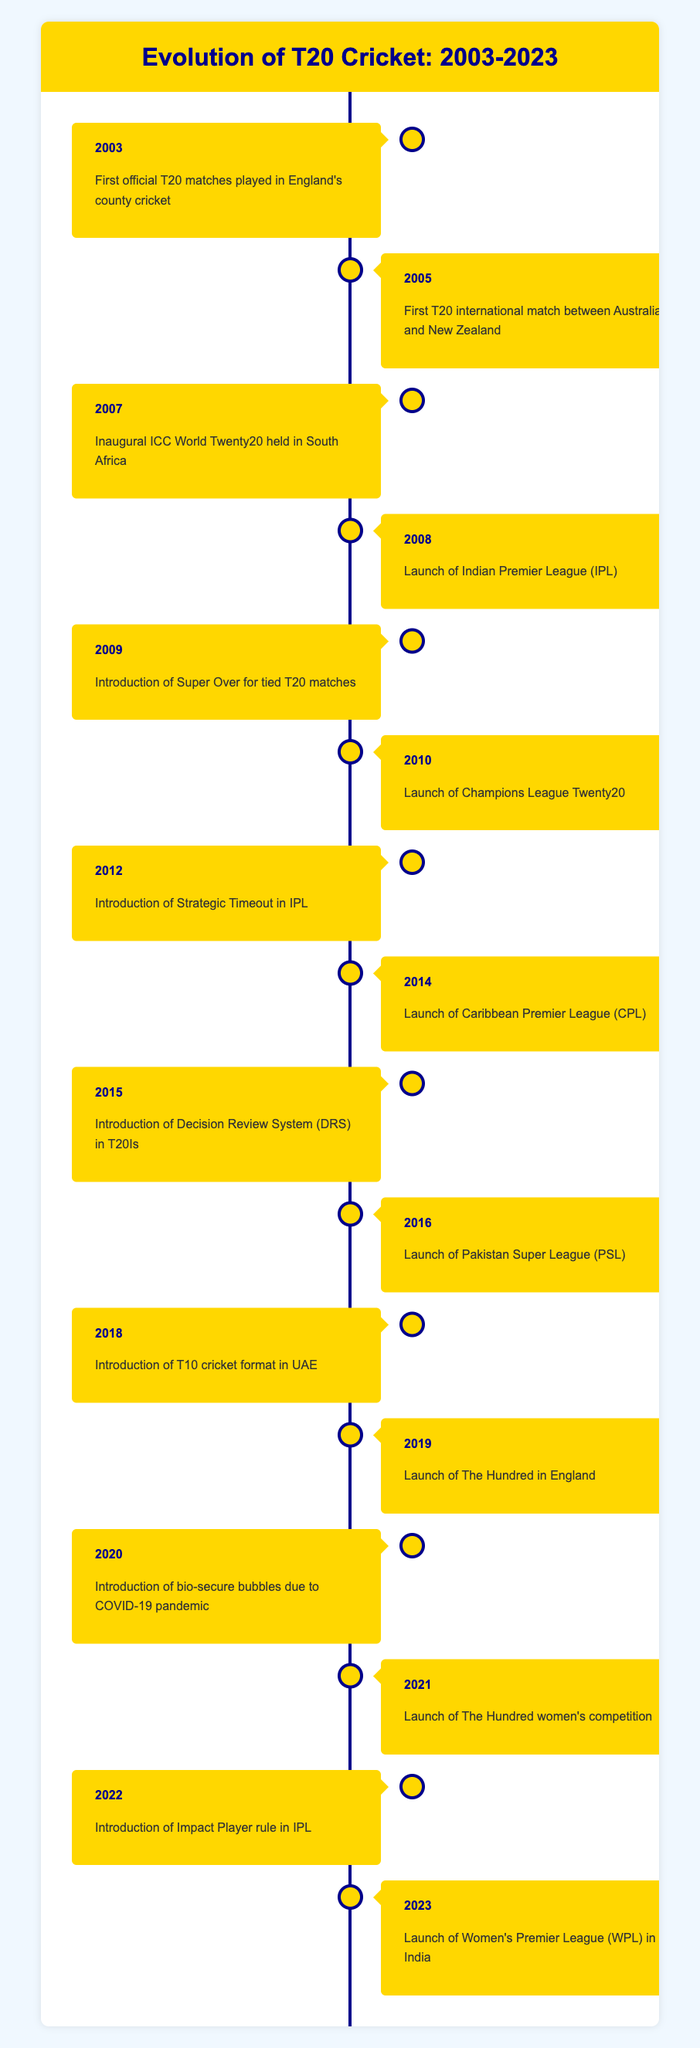What year were the first T20 international matches played? The table indicates that the first T20 international match took place in 2005. This is directly stated in the entry for the year 2005.
Answer: 2005 Which event marks the introduction of the Indian Premier League? According to the table, the launch of the Indian Premier League (IPL) occurred in 2008. This is explicitly noted for that year.
Answer: 2008 How many years after the introduction of the DRS was the Impact Player rule introduced in IPL? The DRS was introduced in T20 internationals in 2015, and the Impact Player rule was introduced in 2022. To find the difference, subtract 2015 from 2022, resulting in a 7-year gap.
Answer: 7 Was the Women's Premier League launched before the launch of The Hundred? The Women's Premier League (WPL) was launched in 2023, while The Hundred was launched in 2019. Since 2023 is after 2019, the statement is false.
Answer: No How many significant T20 cricket events occurred between 2003 and 2010? Referring to the table, the significant events listed from 2003 to 2010 are: the first official T20 matches in 2003, the first T20 international match in 2005, the inaugural ICC World Twenty20 in 2007, and the launch of the Champions League in 2010, making a total of 4 events.
Answer: 4 Which year saw the introduction of T10 cricket format? The introduction of the T10 cricket format occurred in 2018, as indicated in the corresponding entry in the table.
Answer: 2018 How many new T20 leagues were launched between 2014 and 2016? In the given time frame, the table shows the launch of the Caribbean Premier League in 2014 and the Pakistan Super League in 2016. Therefore, 2 new leagues were launched during this period.
Answer: 2 What was the significance of the events in 2020? The table specifies that in 2020, the introduction of bio-secure bubbles was necessitated by the COVID-19 pandemic, marking a significant adaptation in T20 cricket due to external circumstances.
Answer: Introduction of bio-secure bubbles What is the trend in the introduction of new rules or formats from 2009 to 2023? Analyzing this period, from the introduction of the Super Over in 2009 to the Impact Player rule in 2022 and the launch of the Women's Premier League in 2023, there seems to be a consistent introduction of new rules and formats to enhance the dynamics and inclusiveness of T20 cricket.
Answer: Consistent trend of innovation and inclusion 